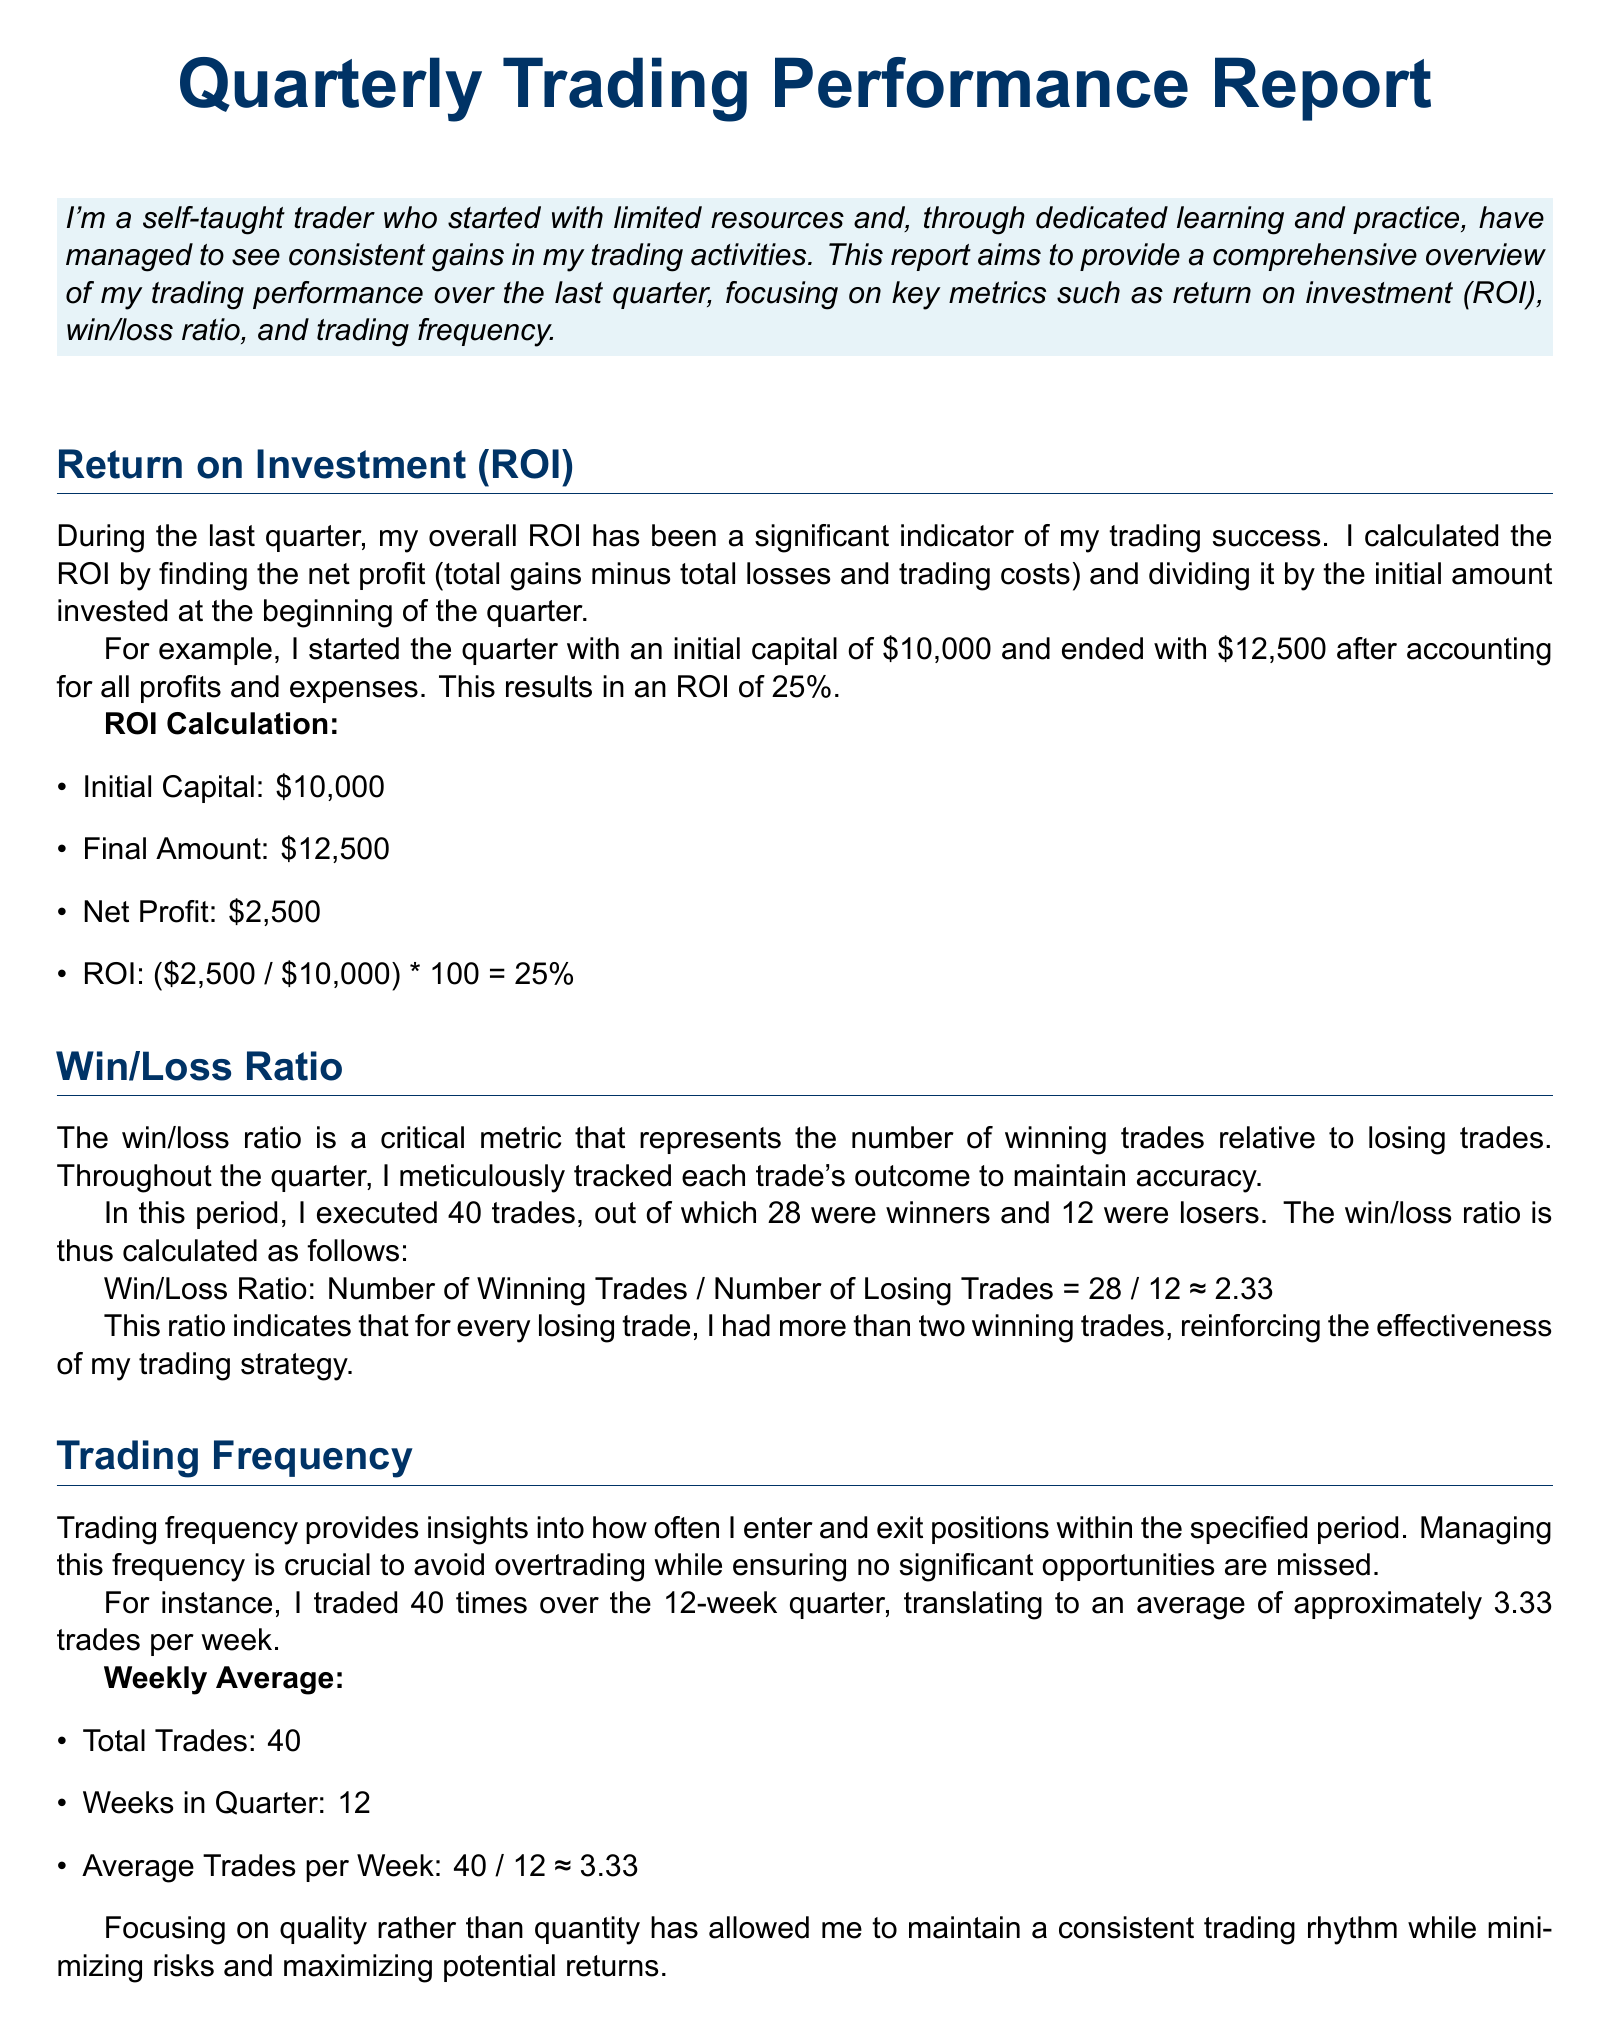What was the initial capital at the beginning of the quarter? The initial capital is the amount of money the trader started with for trading activities, stated as $10,000.
Answer: $10,000 What is the final amount at the end of the quarter? The final amount is the total capital after trading activities over the quarter, which is $12,500.
Answer: $12,500 What is the ROI for the quarter? ROI is calculated as the net profit divided by the initial investment, resulting in 25%.
Answer: 25% How many trades were executed in total during the quarter? This is the total number of individual trades conducted within the quarter, which is stated as 40.
Answer: 40 What is the win/loss ratio calculated for the quarter? The win/loss ratio presents the relationship between winning and losing trades, calculated as 2.33.
Answer: 2.33 How many winning trades were made? This indicates the number of trades that resulted in profit, which is 28.
Answer: 28 What is the average number of trades per week during the quarter? This is calculated by dividing the total trades by the number of weeks in the quarter, which gives approximately 3.33.
Answer: 3.33 How many losing trades were made? This indicates the number of trades that resulted in a loss, which is 12.
Answer: 12 What strategy focus did the trader emphasize during the quarter? The trader's emphasis was on the quality of trades rather than the quantity, reflecting a strategic trading approach.
Answer: Quality over quantity 